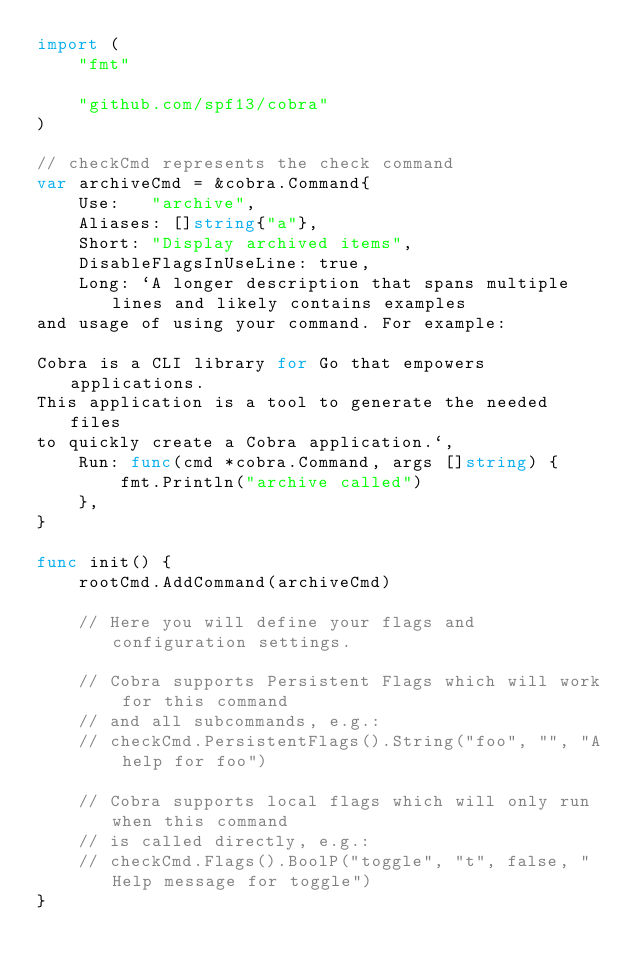Convert code to text. <code><loc_0><loc_0><loc_500><loc_500><_Go_>import (
	"fmt"

	"github.com/spf13/cobra"
)

// checkCmd represents the check command
var archiveCmd = &cobra.Command{
	Use:   "archive",
	Aliases: []string{"a"},
	Short: "Display archived items",
	DisableFlagsInUseLine: true,
	Long: `A longer description that spans multiple lines and likely contains examples
and usage of using your command. For example:

Cobra is a CLI library for Go that empowers applications.
This application is a tool to generate the needed files
to quickly create a Cobra application.`,
	Run: func(cmd *cobra.Command, args []string) {
		fmt.Println("archive called")
	},
}

func init() {
	rootCmd.AddCommand(archiveCmd)

	// Here you will define your flags and configuration settings.

	// Cobra supports Persistent Flags which will work for this command
	// and all subcommands, e.g.:
	// checkCmd.PersistentFlags().String("foo", "", "A help for foo")

	// Cobra supports local flags which will only run when this command
	// is called directly, e.g.:
	// checkCmd.Flags().BoolP("toggle", "t", false, "Help message for toggle")
}
</code> 